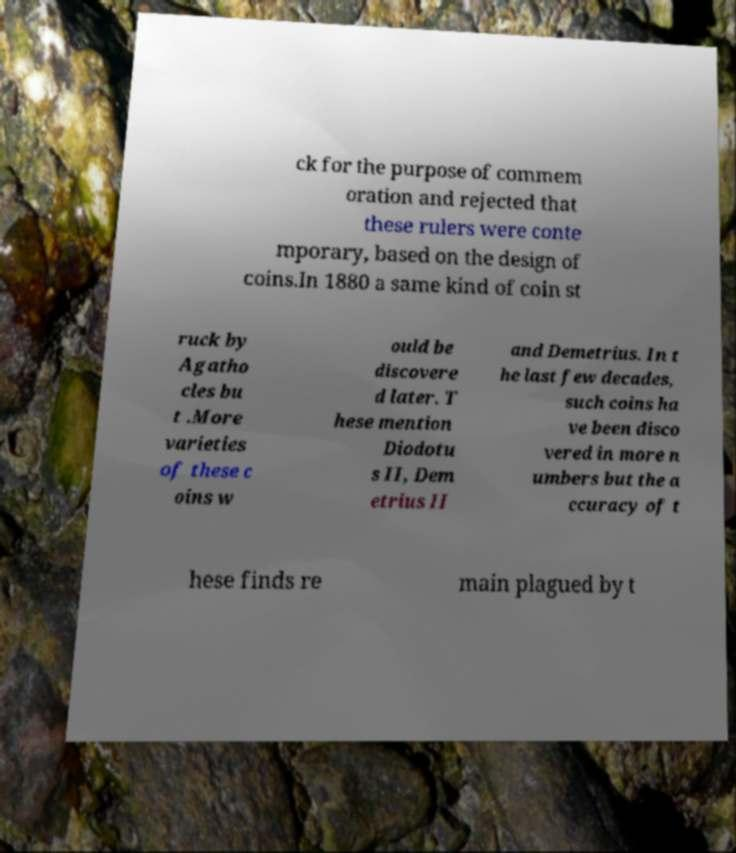What messages or text are displayed in this image? I need them in a readable, typed format. ck for the purpose of commem oration and rejected that these rulers were conte mporary, based on the design of coins.In 1880 a same kind of coin st ruck by Agatho cles bu t .More varieties of these c oins w ould be discovere d later. T hese mention Diodotu s II, Dem etrius II and Demetrius. In t he last few decades, such coins ha ve been disco vered in more n umbers but the a ccuracy of t hese finds re main plagued by t 